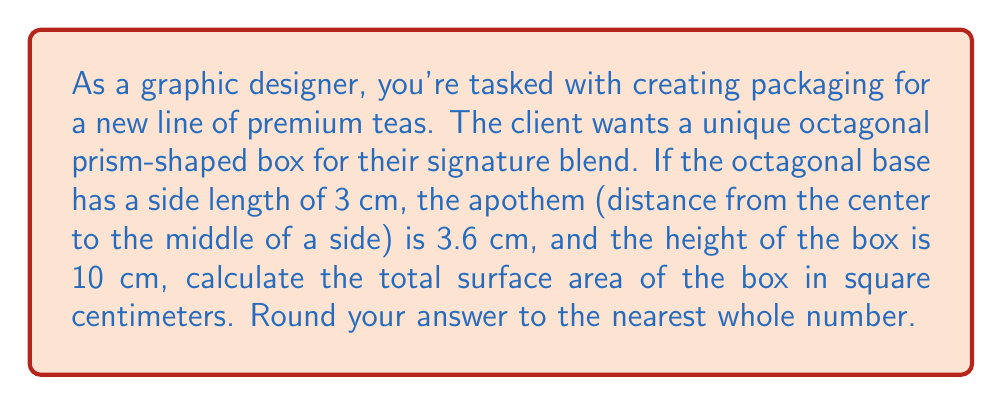What is the answer to this math problem? To solve this problem, we need to calculate the surface area of the octagonal prism, which consists of the top and bottom octagonal faces and eight rectangular side faces.

1. Calculate the area of one octagonal face:
   The area of a regular octagon is given by the formula:
   $$A_{octagon} = 2a^2(1+\sqrt{2})$$
   where $a$ is the side length.
   
   $$A_{octagon} = 2(3^2)(1+\sqrt{2}) = 18(1+\sqrt{2}) \approx 43.4314 \text{ cm}^2$$

2. Calculate the area of all rectangular side faces:
   The perimeter of the octagon is $8 \times 3 = 24$ cm.
   Area of side faces = perimeter × height
   $$A_{sides} = 24 \times 10 = 240 \text{ cm}^2$$

3. Calculate the total surface area:
   $$A_{total} = 2A_{octagon} + A_{sides}$$
   $$A_{total} = 2(43.4314) + 240 = 326.8628 \text{ cm}^2$$

4. Round to the nearest whole number:
   326.8628 rounds to 327 cm²

[asy]
import geometry;

// Draw octagonal base
pair[] octagon;
for(int i=0; i<8; ++i) {
  octagon.push(3.6*dir(45*i));
}
filldraw(polygon(octagon), lightgray);

// Draw height
draw((0,0)--(0,10), dashed);

// Label
label("3 cm", (1.8,0), S);
label("10 cm", (0,5), E);
label("3.6 cm", (0,0)--(1.8,1.8), NW);
[/asy]
Answer: 327 cm² 